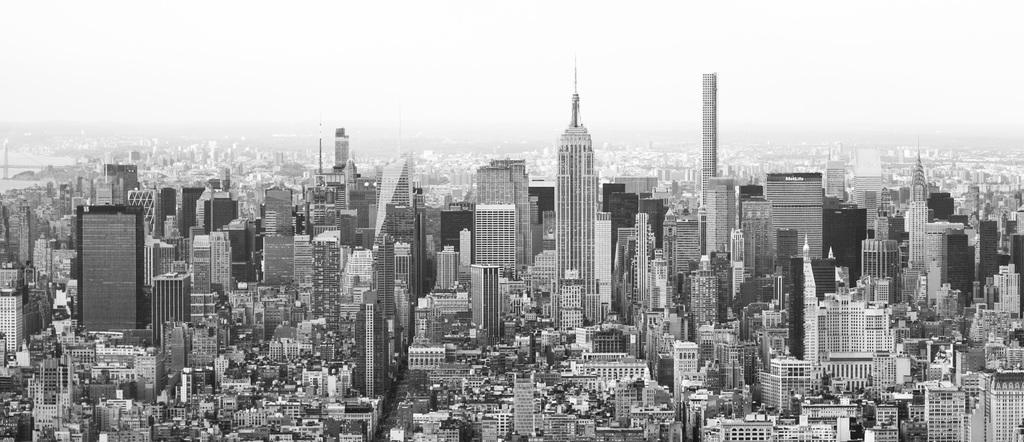What is the color scheme of the image? The image is black and white. What type of structures can be seen in the image? There are many buildings visible in the image. What part of the natural environment is visible in the image? The sky is visible in the image. What type of quilt is being used to cover the buildings in the image? There is no quilt present in the image; it features black and white buildings with the sky visible. 